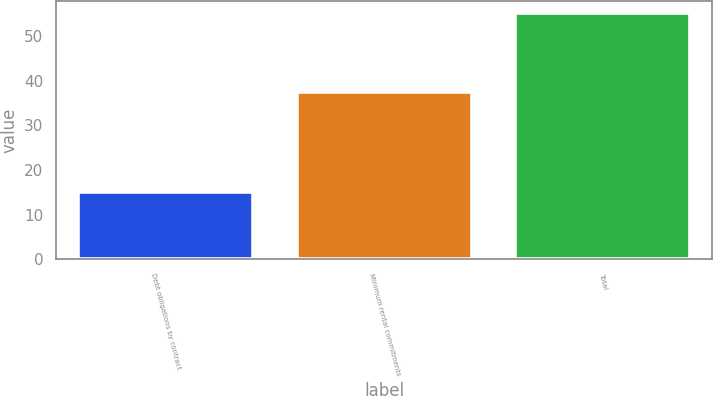Convert chart. <chart><loc_0><loc_0><loc_500><loc_500><bar_chart><fcel>Debt obligations by contract<fcel>Minimum rental commitments<fcel>Total<nl><fcel>15<fcel>37.4<fcel>55.1<nl></chart> 